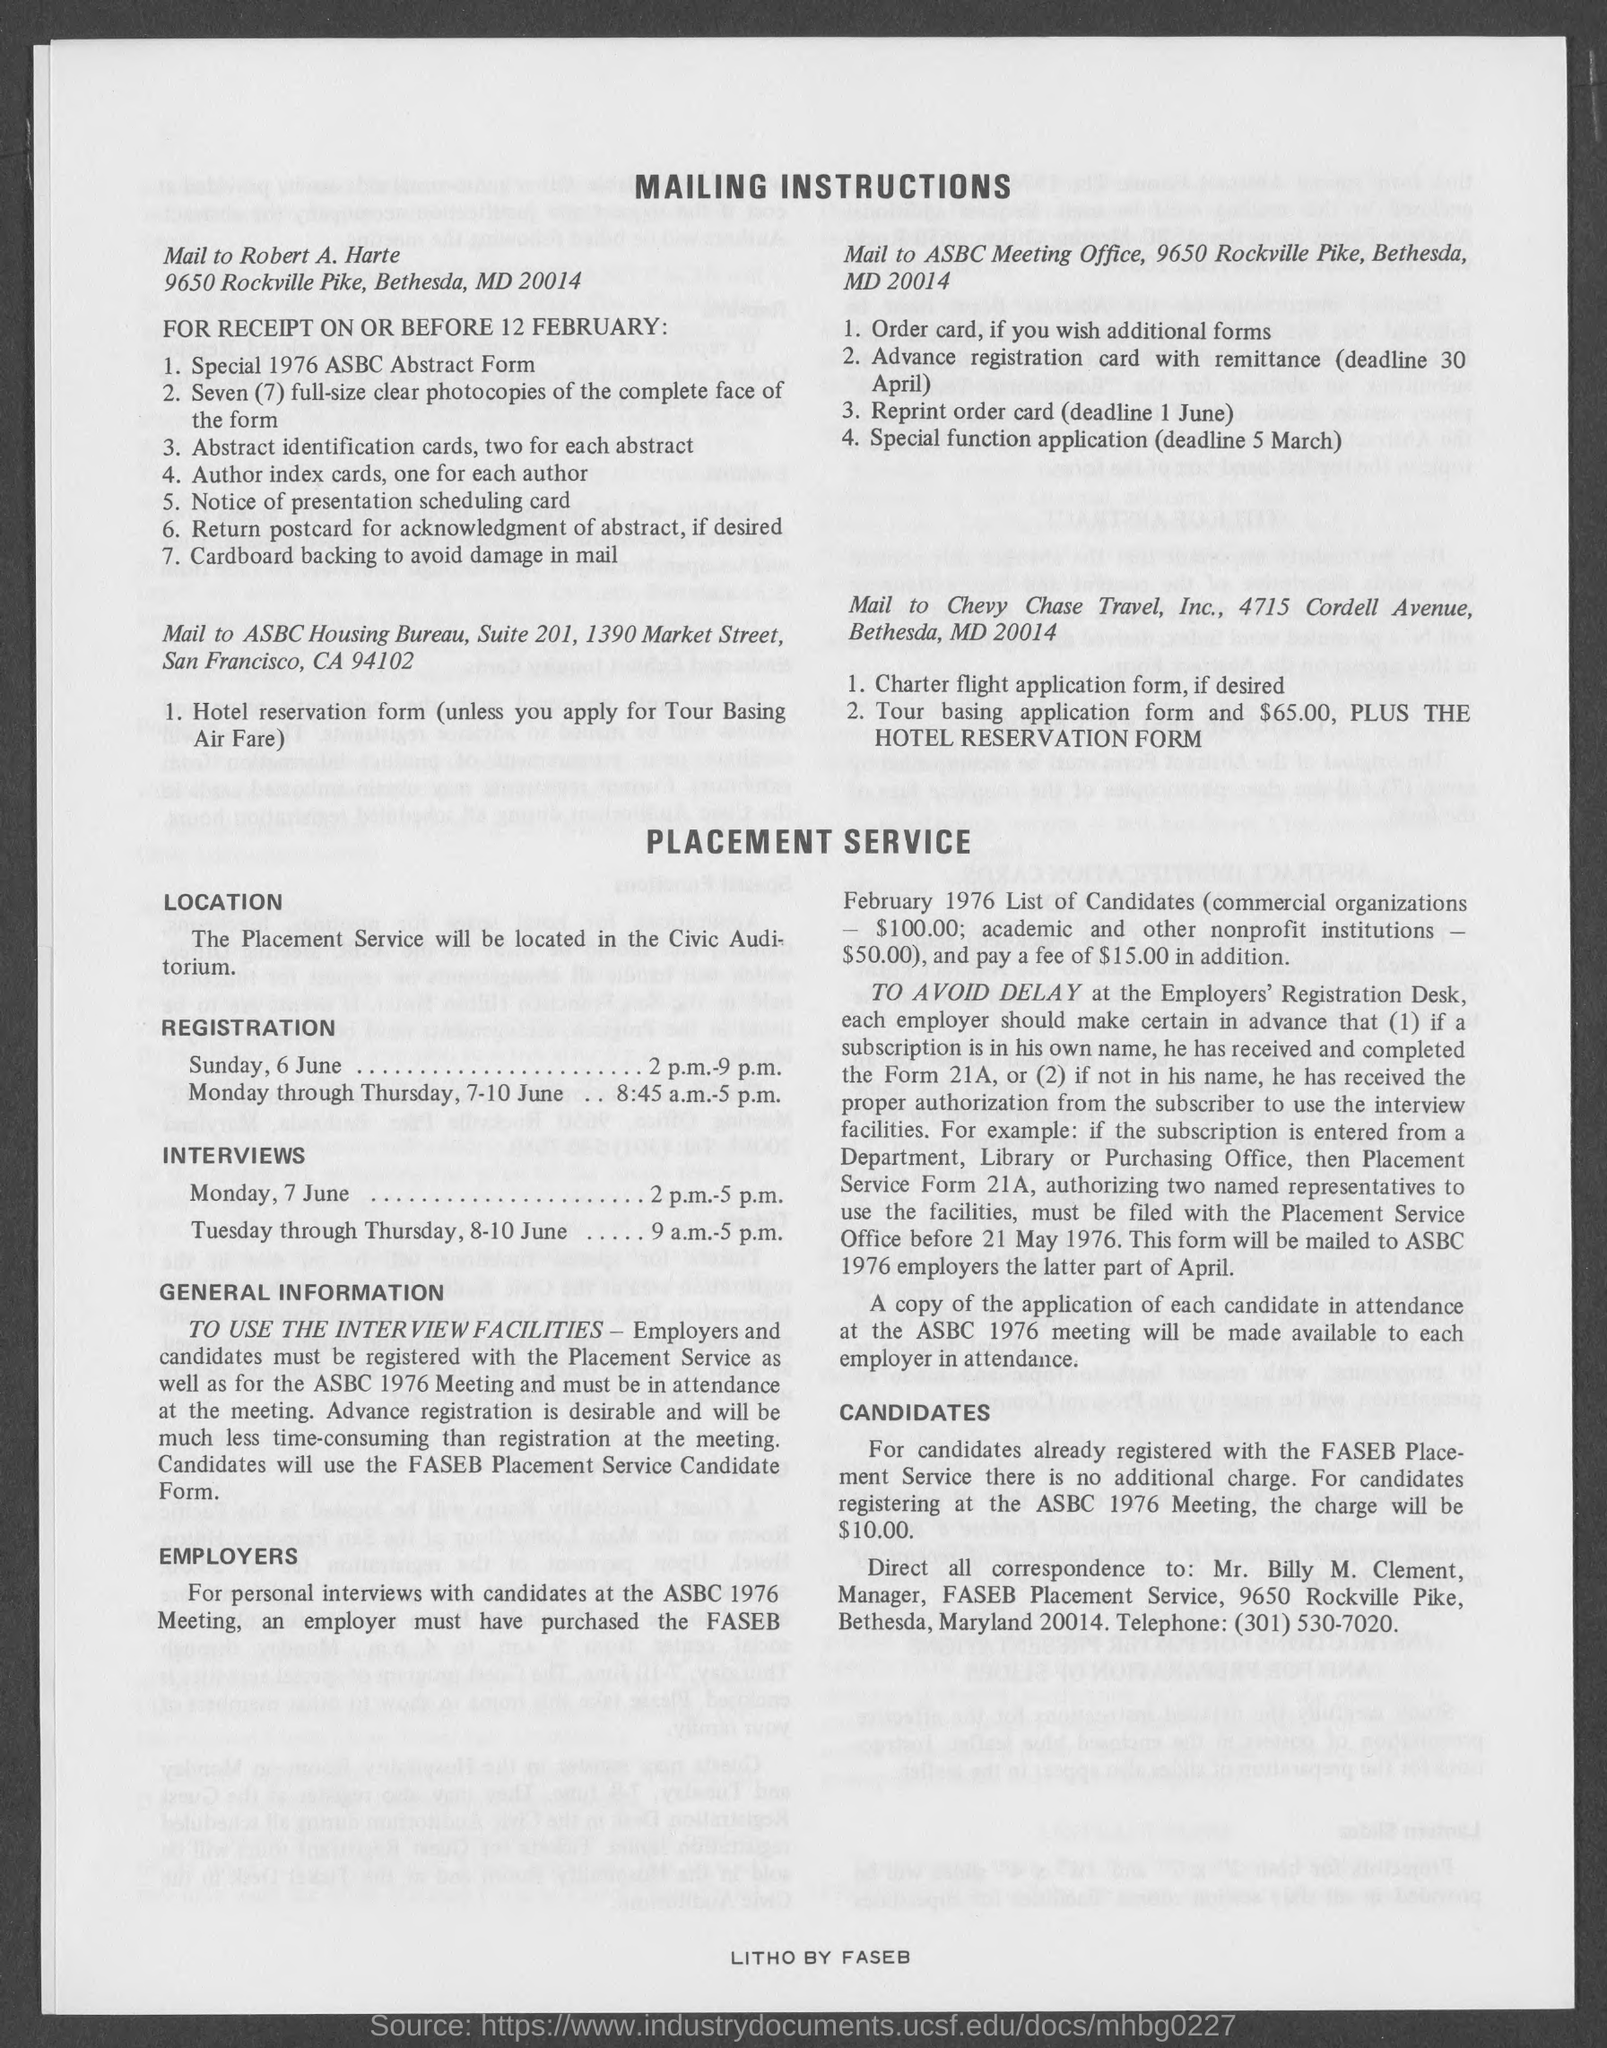Identify some key points in this picture. The title of the document is 'Mailing Instructions'. The Placement service is located at the Civic Auditorium. 